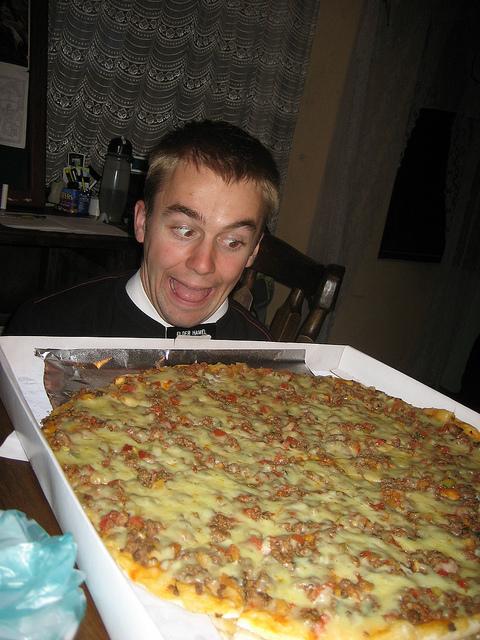Is the man putting on a face or is he really scared of the size of the pizza?
Answer briefly. Putting on face. What gender is the kid?
Short answer required. Male. Do you expect more people to eat the pizza?
Short answer required. Yes. Is this pizza unusually large?
Write a very short answer. Yes. 